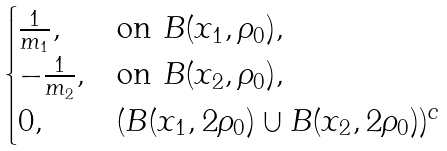Convert formula to latex. <formula><loc_0><loc_0><loc_500><loc_500>\begin{cases} \frac { 1 } { m _ { 1 } } , & \text {on $B(x_{1},\rho_{0})$} , \\ - \frac { 1 } { m _ { 2 } } , & \text {on $B(x_{2},\rho_{0})$} , \\ 0 , & \text {$(B(x_{1},2\rho_{0})\cup B(x_{2},2\rho_{0}))^{c}$} \end{cases}</formula> 